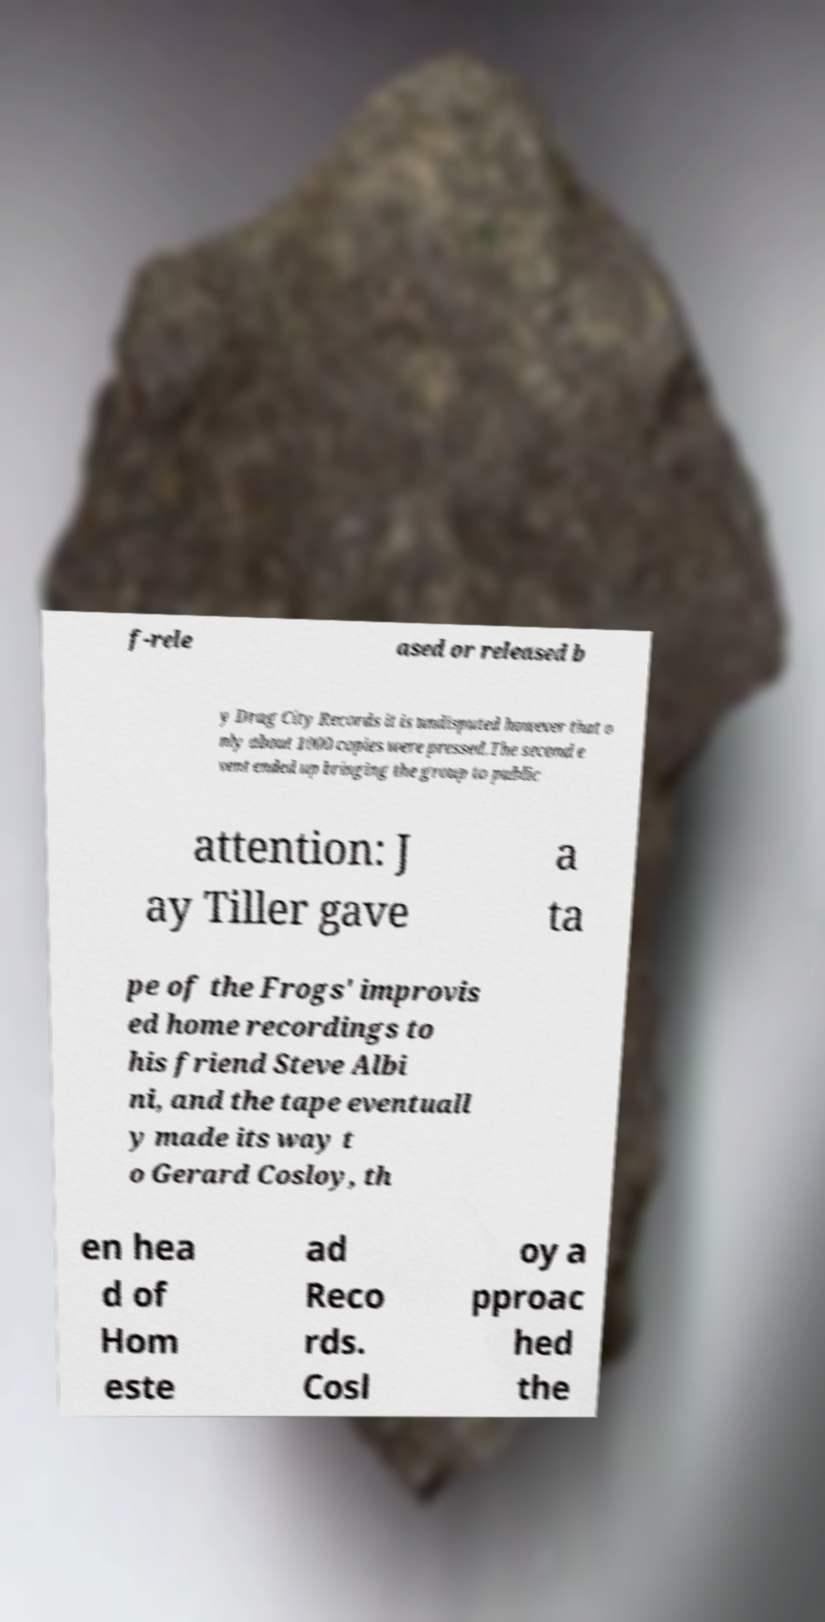I need the written content from this picture converted into text. Can you do that? f-rele ased or released b y Drag City Records it is undisputed however that o nly about 1000 copies were pressed.The second e vent ended up bringing the group to public attention: J ay Tiller gave a ta pe of the Frogs' improvis ed home recordings to his friend Steve Albi ni, and the tape eventuall y made its way t o Gerard Cosloy, th en hea d of Hom este ad Reco rds. Cosl oy a pproac hed the 